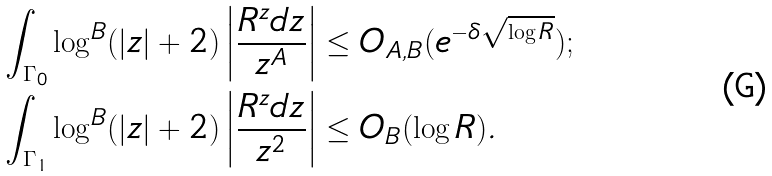<formula> <loc_0><loc_0><loc_500><loc_500>\int _ { \Gamma _ { 0 } } \log ^ { B } ( | z | + 2 ) \left | \frac { R ^ { z } d z } { z ^ { A } } \right | & \leq O _ { A , B } ( e ^ { - \delta \sqrt { \log R } } ) ; \\ \int _ { \Gamma _ { 1 } } \log ^ { B } ( | z | + 2 ) \left | \frac { R ^ { z } d z } { z ^ { 2 } } \right | & \leq O _ { B } ( \log R ) .</formula> 